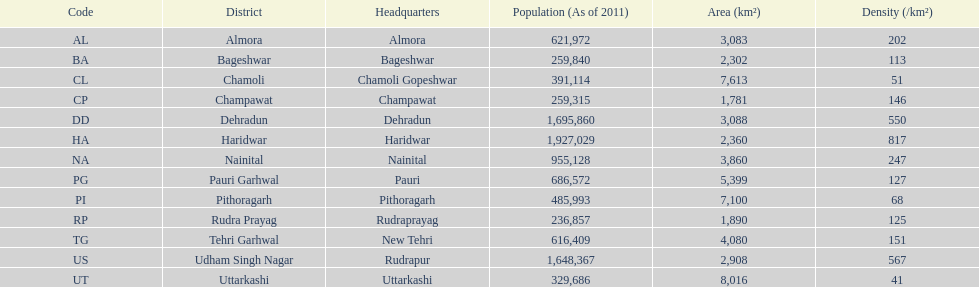Which code is higher than cl? BA. 